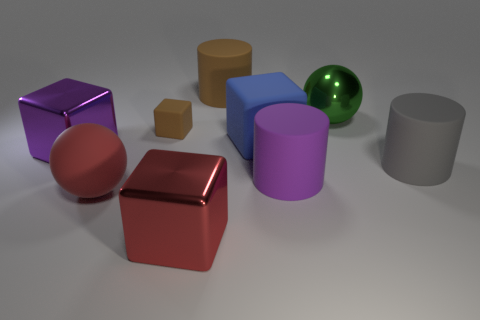Is there any other thing that has the same size as the brown matte block?
Your answer should be very brief. No. Is the material of the large green sphere the same as the brown object to the left of the big brown cylinder?
Your answer should be very brief. No. There is a brown rubber thing that is the same shape as the big red metal object; what is its size?
Provide a succinct answer. Small. Are there an equal number of rubber cubes that are in front of the purple matte cylinder and large purple objects that are behind the big gray matte cylinder?
Provide a succinct answer. No. What number of other objects are the same material as the brown cylinder?
Provide a succinct answer. 5. Is the number of big purple matte objects that are behind the purple shiny thing the same as the number of small yellow shiny blocks?
Offer a terse response. Yes. There is a rubber sphere; does it have the same size as the rubber cylinder that is behind the large metallic sphere?
Offer a very short reply. Yes. There is a large purple thing behind the gray matte cylinder; what is its shape?
Keep it short and to the point. Cube. Are there any other things that have the same shape as the tiny brown matte object?
Make the answer very short. Yes. Are any tiny blue matte blocks visible?
Offer a terse response. No. 